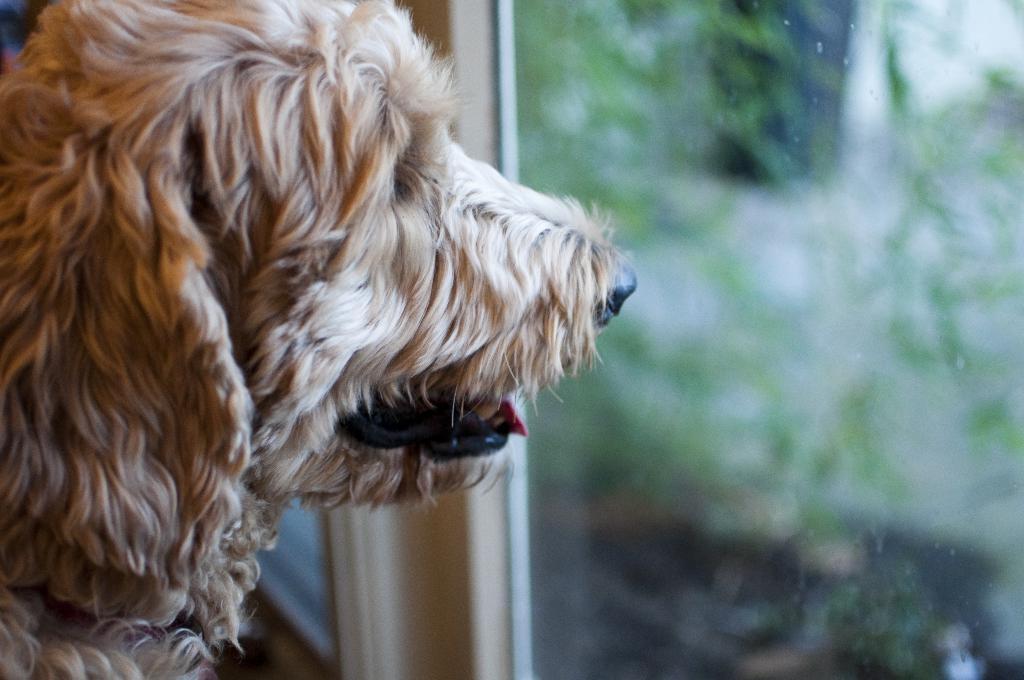Describe this image in one or two sentences. In this image there is a dog looking outside the window. 